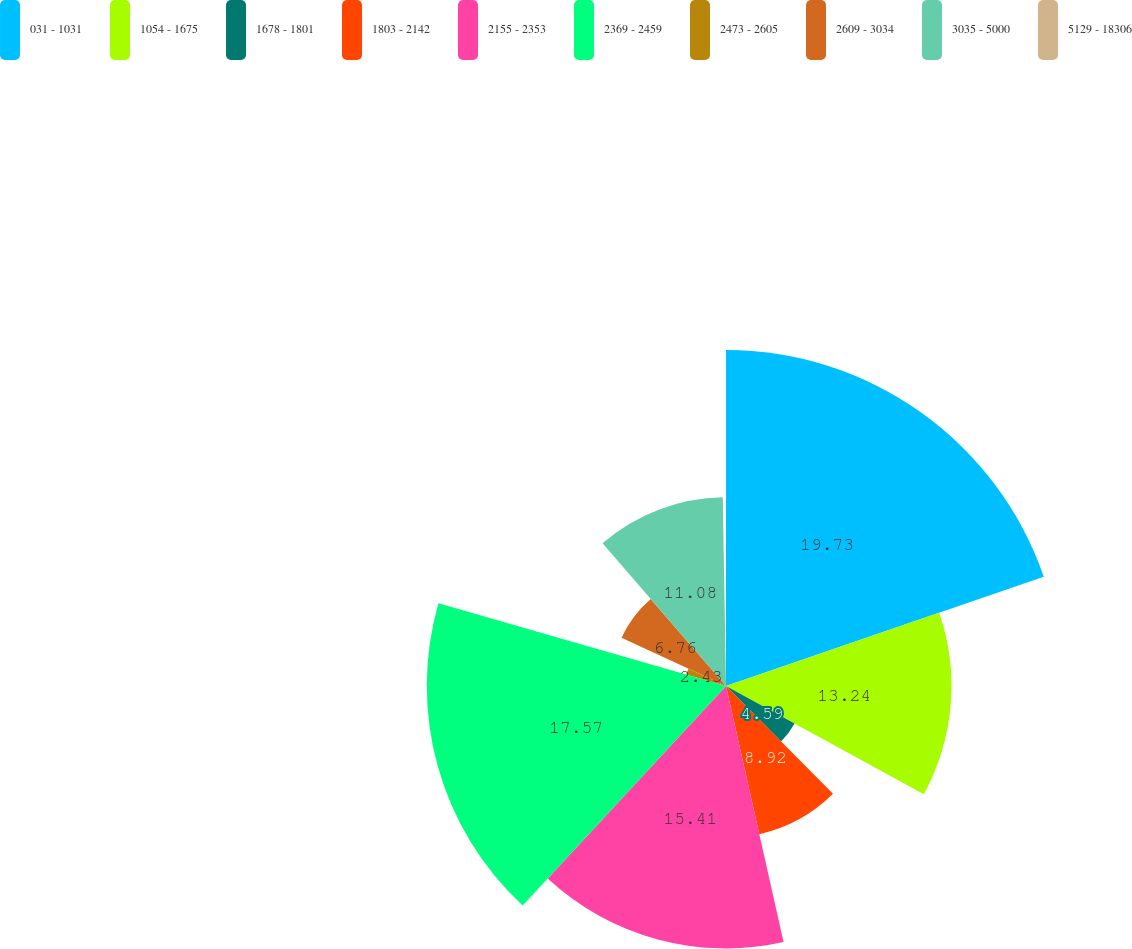Convert chart to OTSL. <chart><loc_0><loc_0><loc_500><loc_500><pie_chart><fcel>031 - 1031<fcel>1054 - 1675<fcel>1678 - 1801<fcel>1803 - 2142<fcel>2155 - 2353<fcel>2369 - 2459<fcel>2473 - 2605<fcel>2609 - 3034<fcel>3035 - 5000<fcel>5129 - 18306<nl><fcel>19.73%<fcel>13.24%<fcel>4.59%<fcel>8.92%<fcel>15.41%<fcel>17.57%<fcel>2.43%<fcel>6.76%<fcel>11.08%<fcel>0.27%<nl></chart> 